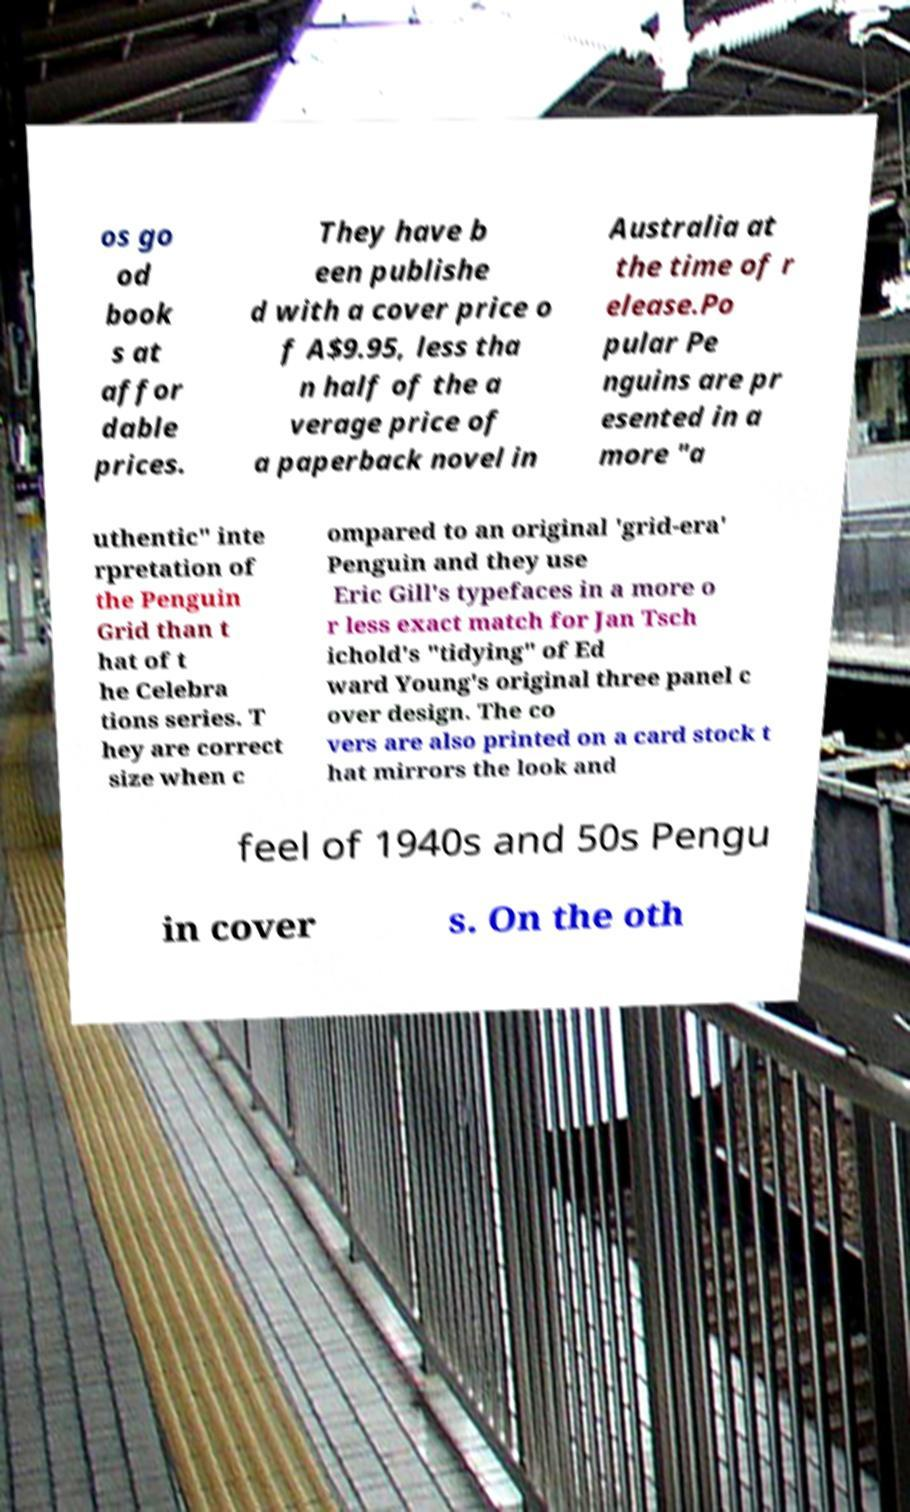There's text embedded in this image that I need extracted. Can you transcribe it verbatim? os go od book s at affor dable prices. They have b een publishe d with a cover price o f A$9.95, less tha n half of the a verage price of a paperback novel in Australia at the time of r elease.Po pular Pe nguins are pr esented in a more "a uthentic" inte rpretation of the Penguin Grid than t hat of t he Celebra tions series. T hey are correct size when c ompared to an original 'grid-era' Penguin and they use Eric Gill's typefaces in a more o r less exact match for Jan Tsch ichold's "tidying" of Ed ward Young's original three panel c over design. The co vers are also printed on a card stock t hat mirrors the look and feel of 1940s and 50s Pengu in cover s. On the oth 